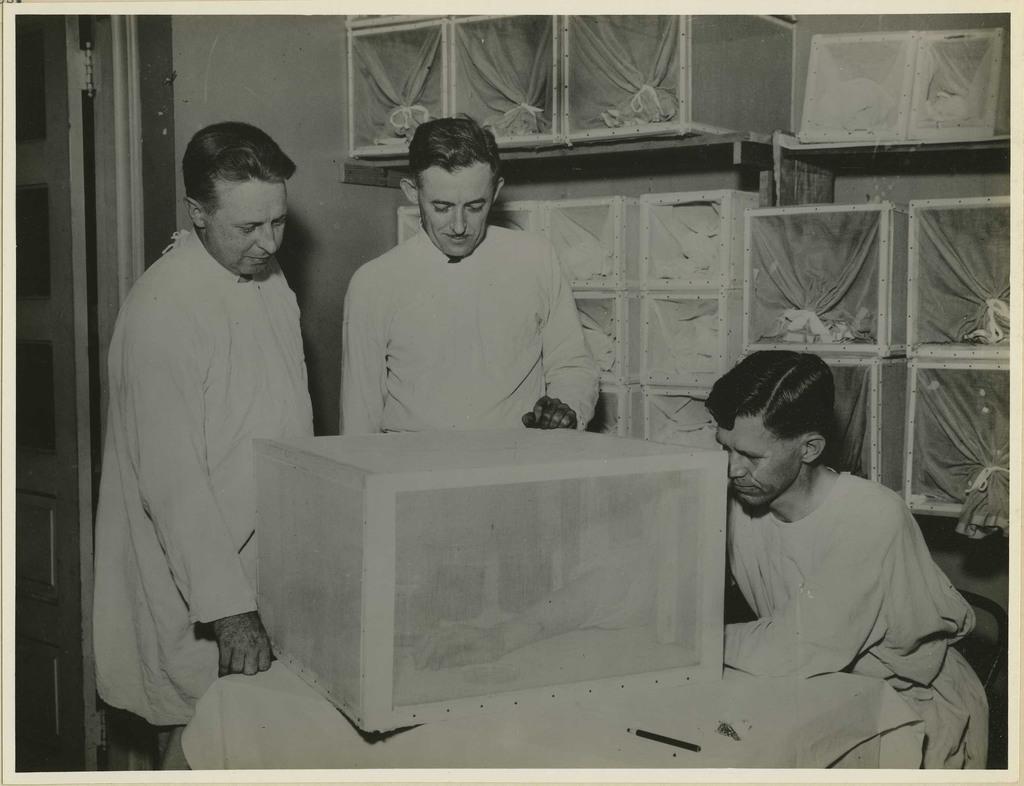Describe this image in one or two sentences. This is a black and white image. In the center of the image there are three persons. There is some object on the table. There is a door at the left side of the image. 